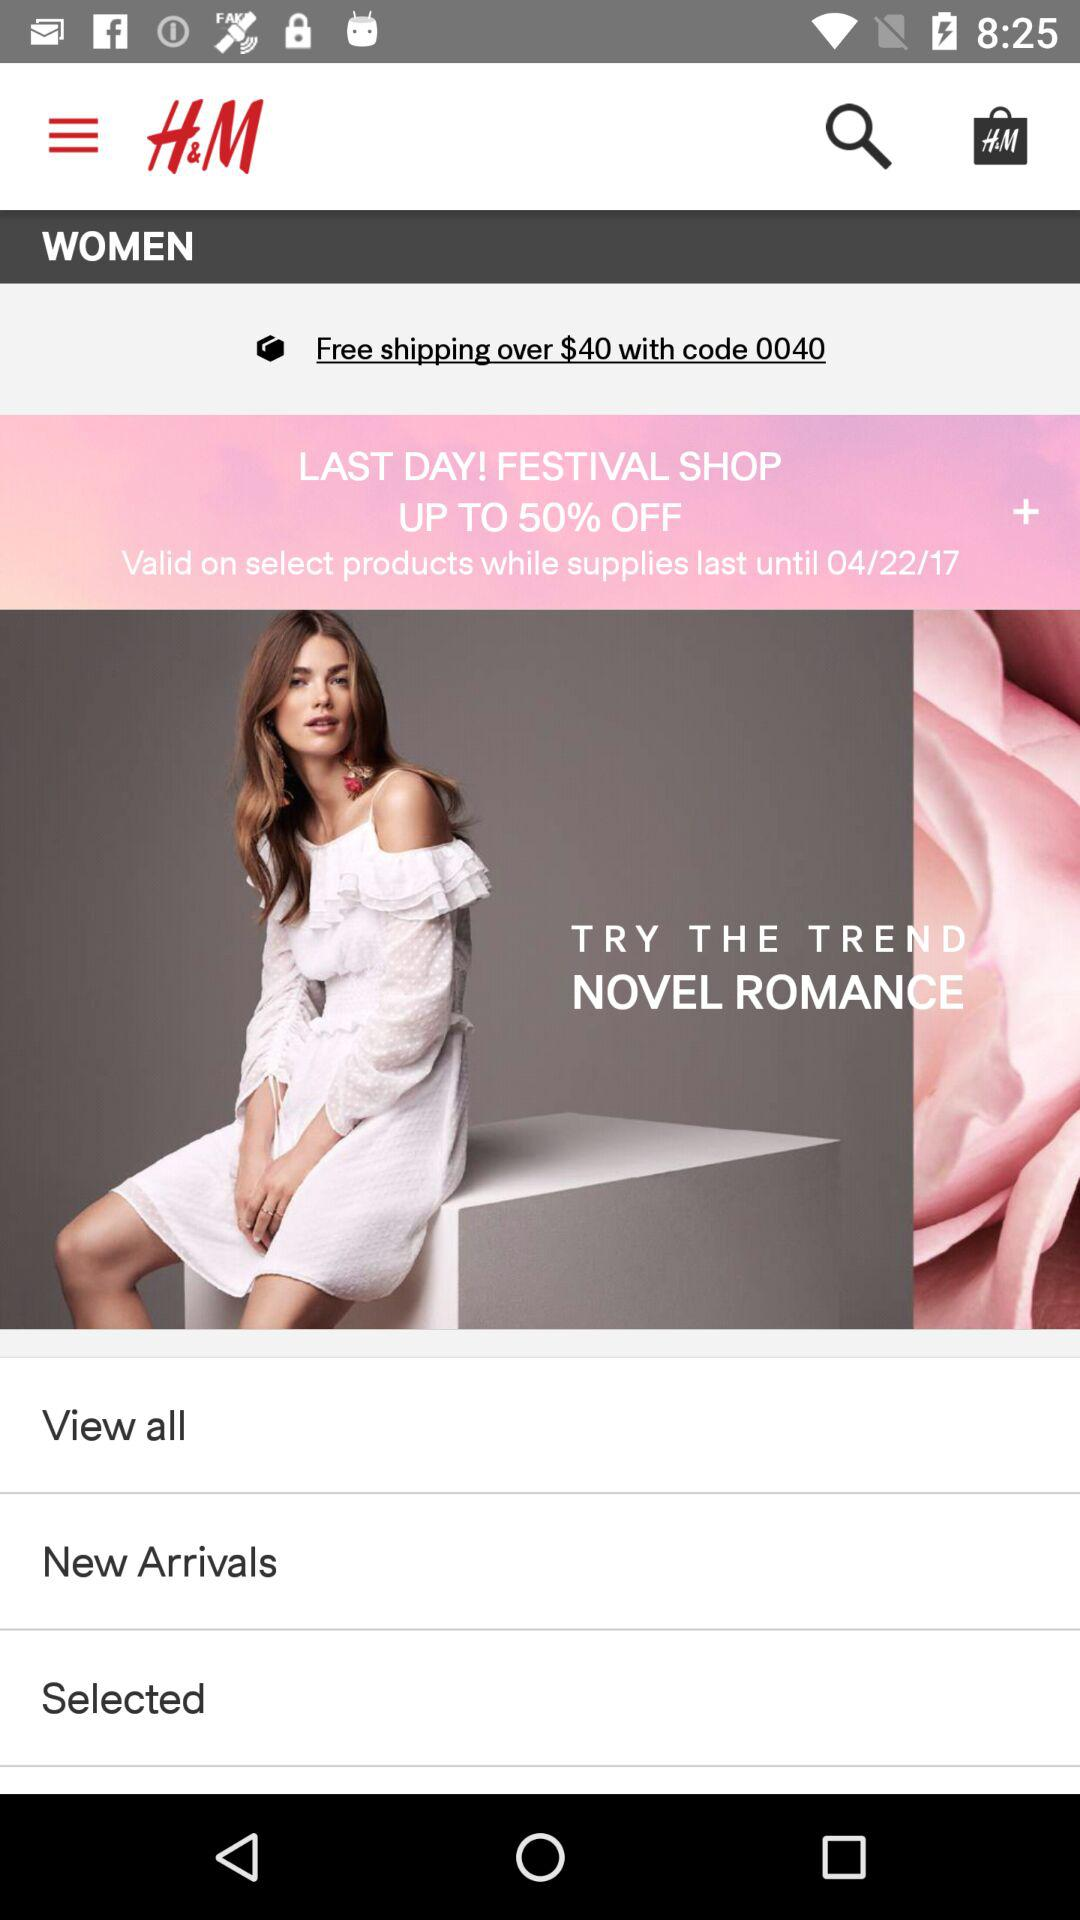To what amount is free shipping applicable? Free shipping is available on orders over $40. 